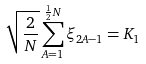<formula> <loc_0><loc_0><loc_500><loc_500>\sqrt { \frac { 2 } { N } } \sum _ { A = 1 } ^ { \frac { 1 } { 2 } N } \xi _ { 2 A - 1 } = K _ { 1 }</formula> 